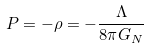Convert formula to latex. <formula><loc_0><loc_0><loc_500><loc_500>P = - \rho = - \frac { \Lambda } { 8 \pi G _ { N } }</formula> 